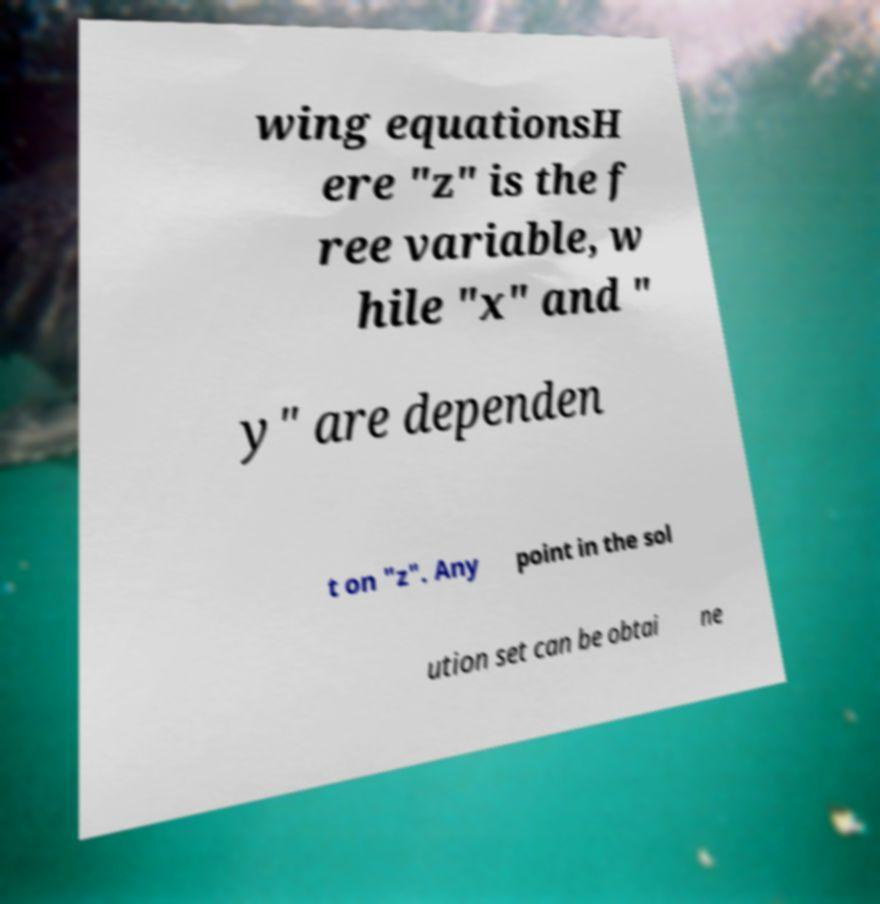There's text embedded in this image that I need extracted. Can you transcribe it verbatim? wing equationsH ere "z" is the f ree variable, w hile "x" and " y" are dependen t on "z". Any point in the sol ution set can be obtai ne 